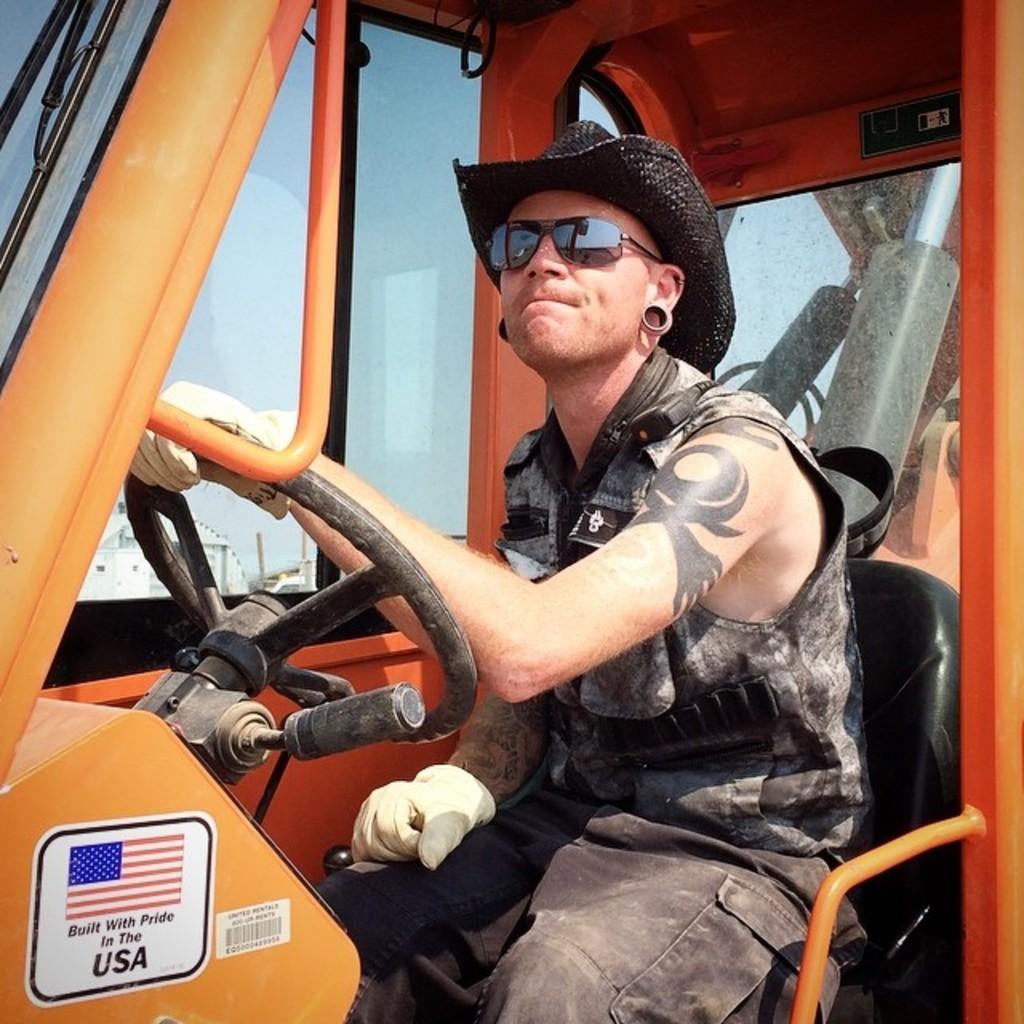Could you give a brief overview of what you see in this image? In the middle of the image a man is sitting on a vehicle. Behind him there is sky. 